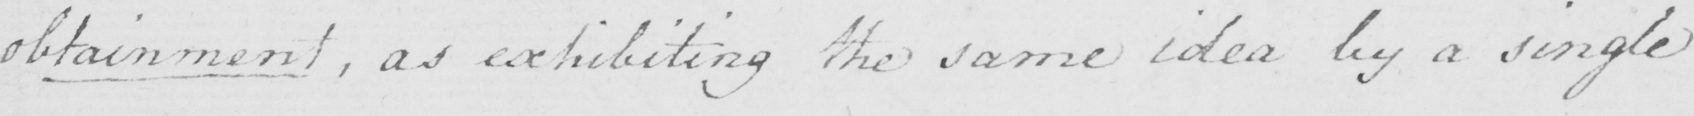Transcribe the text shown in this historical manuscript line. obtainment , exhibiting the same idea by a single 